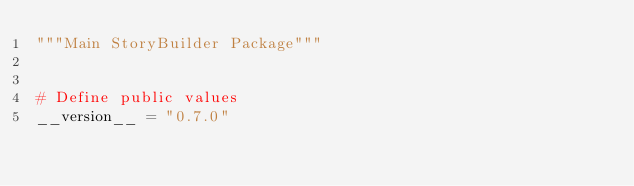<code> <loc_0><loc_0><loc_500><loc_500><_Python_>"""Main StoryBuilder Package"""


# Define public values
__version__ = "0.7.0"

</code> 